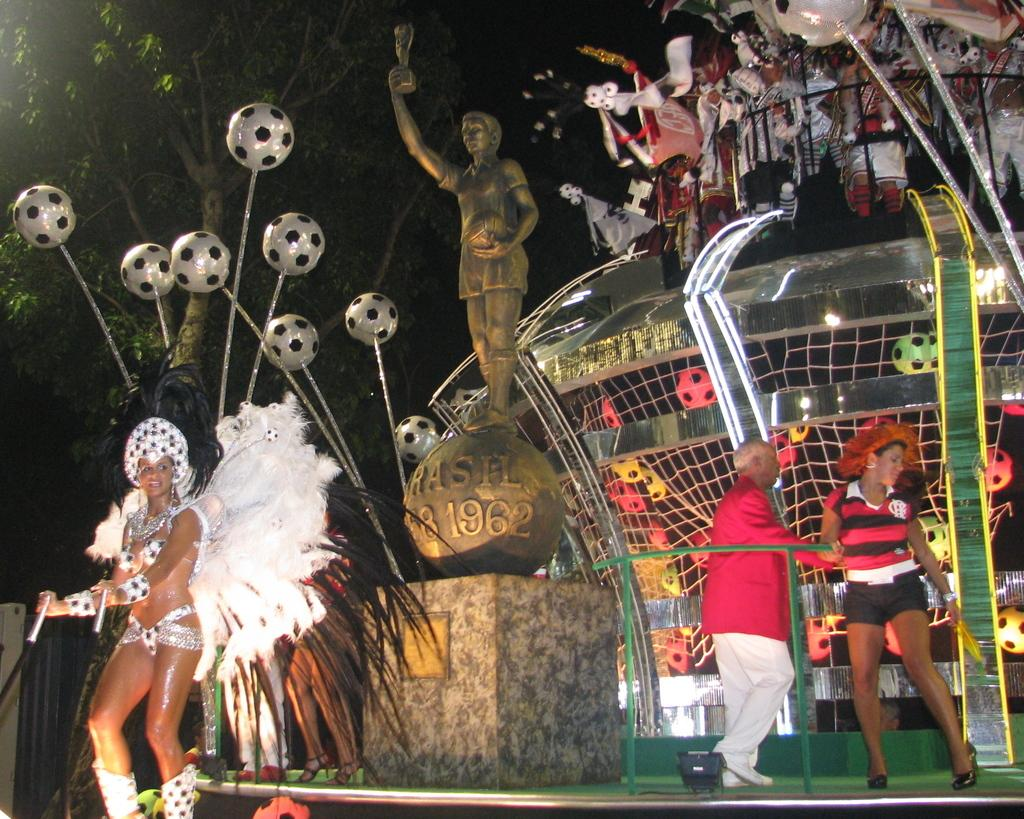What can be seen in the foreground of the image? There are people in the foreground of the image. What type of objects are present in the image? There are balls, which may be toys, in the image, as well as a sculpture and other objects. What is visible in the background of the image? There is a tree in the background of the image. What is the angle of the country in the image? There is no country present in the image, so it is not possible to determine its angle. How can the adjustment of the objects in the image be improved? The question assumes that the objects in the image need adjustment, which is not mentioned in the provided facts. 